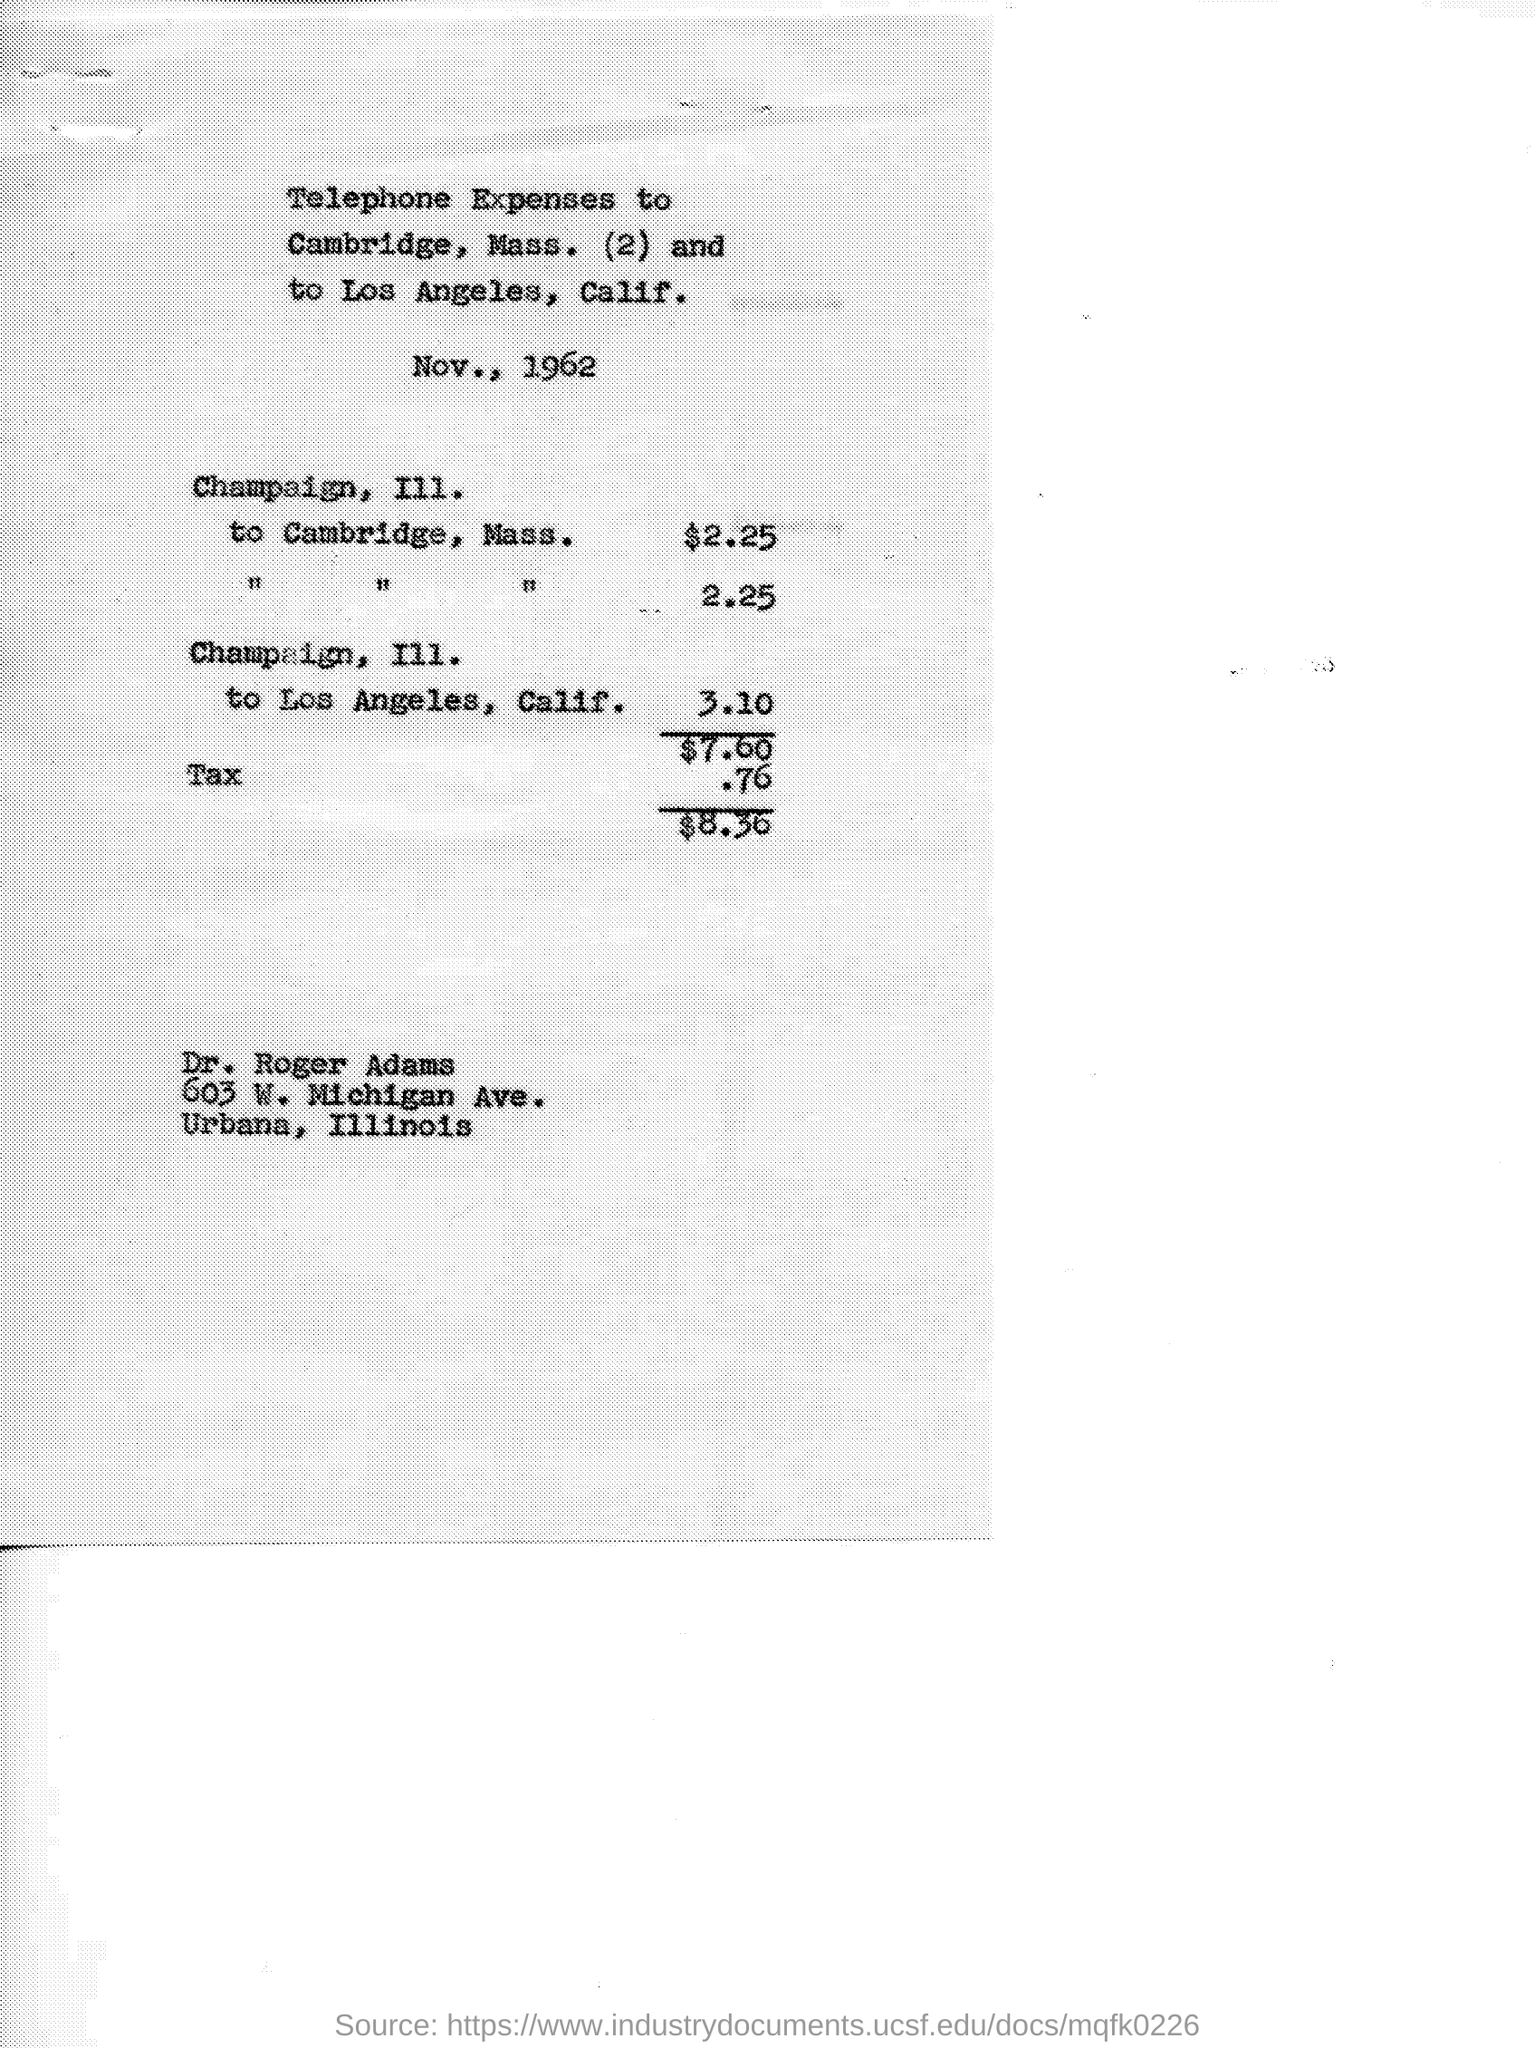What is  this about?
Your response must be concise. Telephone Expenses. How many dollars were used in Champaign III. to Cambridge, Mass.?
Provide a succinct answer. $2.25. What's the amount added as tax?
Offer a terse response. .76. 